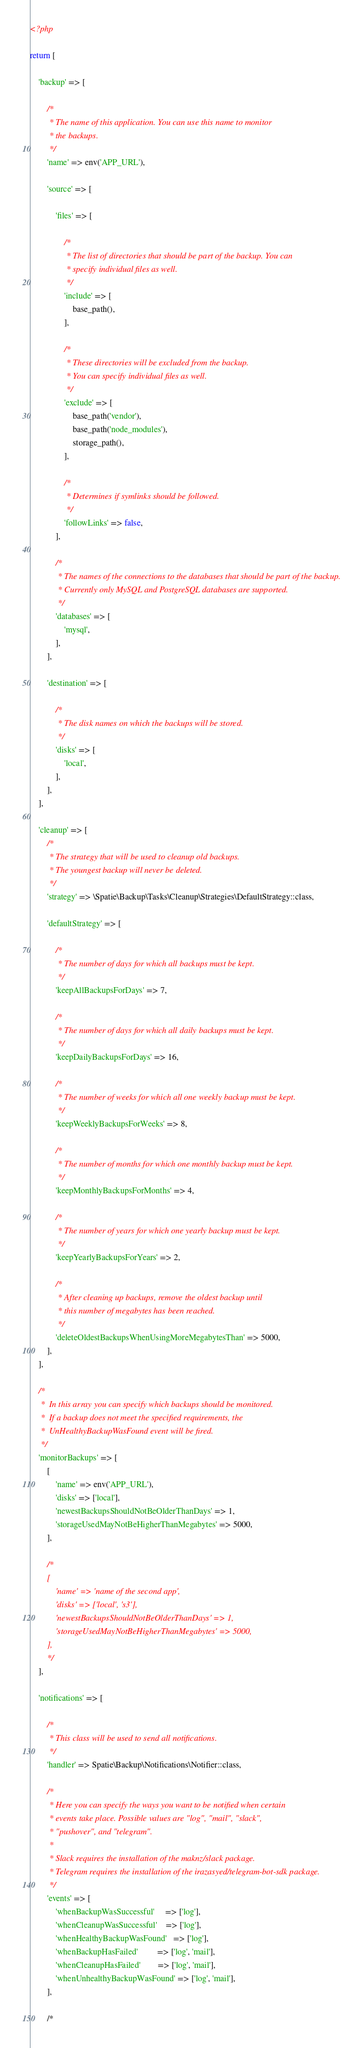<code> <loc_0><loc_0><loc_500><loc_500><_PHP_><?php

return [

    'backup' => [

        /*
         * The name of this application. You can use this name to monitor
         * the backups.
         */
        'name' => env('APP_URL'),

        'source' => [

            'files' => [

                /*
                 * The list of directories that should be part of the backup. You can
                 * specify individual files as well.
                 */
                'include' => [
                    base_path(),
                ],

                /*
                 * These directories will be excluded from the backup.
                 * You can specify individual files as well.
                 */
                'exclude' => [
                    base_path('vendor'),
                    base_path('node_modules'),
                    storage_path(),
                ],

                /*
                 * Determines if symlinks should be followed.
                 */
                'followLinks' => false,
            ],

            /*
             * The names of the connections to the databases that should be part of the backup.
             * Currently only MySQL and PostgreSQL databases are supported.
             */
            'databases' => [
                'mysql',
            ],
        ],

        'destination' => [

            /*
             * The disk names on which the backups will be stored.
             */
            'disks' => [
                'local',
            ],
        ],
    ],

    'cleanup' => [
        /*
         * The strategy that will be used to cleanup old backups.
         * The youngest backup will never be deleted.
         */
        'strategy' => \Spatie\Backup\Tasks\Cleanup\Strategies\DefaultStrategy::class,

        'defaultStrategy' => [

            /*
             * The number of days for which all backups must be kept.
             */
            'keepAllBackupsForDays' => 7,

            /*
             * The number of days for which all daily backups must be kept.
             */
            'keepDailyBackupsForDays' => 16,

            /*
             * The number of weeks for which all one weekly backup must be kept.
             */
            'keepWeeklyBackupsForWeeks' => 8,

            /*
             * The number of months for which one monthly backup must be kept.
             */
            'keepMonthlyBackupsForMonths' => 4,

            /*
             * The number of years for which one yearly backup must be kept.
             */
            'keepYearlyBackupsForYears' => 2,

            /*
             * After cleaning up backups, remove the oldest backup until
             * this number of megabytes has been reached.
             */
            'deleteOldestBackupsWhenUsingMoreMegabytesThan' => 5000,
        ],
    ],

    /*
     *  In this array you can specify which backups should be monitored.
     *  If a backup does not meet the specified requirements, the
     *  UnHealthyBackupWasFound event will be fired.
     */
    'monitorBackups' => [
        [
            'name' => env('APP_URL'),
            'disks' => ['local'],
            'newestBackupsShouldNotBeOlderThanDays' => 1,
            'storageUsedMayNotBeHigherThanMegabytes' => 5000,
        ],

        /*
        [
            'name' => 'name of the second app',
            'disks' => ['local', 's3'],
            'newestBackupsShouldNotBeOlderThanDays' => 1,
            'storageUsedMayNotBeHigherThanMegabytes' => 5000,
        ],
        */
    ],

    'notifications' => [

        /*
         * This class will be used to send all notifications.
         */
        'handler' => Spatie\Backup\Notifications\Notifier::class,

        /*
         * Here you can specify the ways you want to be notified when certain
         * events take place. Possible values are "log", "mail", "slack",
         * "pushover", and "telegram".
         *
         * Slack requires the installation of the maknz/slack package.
         * Telegram requires the installation of the irazasyed/telegram-bot-sdk package.
         */
        'events' => [
            'whenBackupWasSuccessful'     => ['log'],
            'whenCleanupWasSuccessful'    => ['log'],
            'whenHealthyBackupWasFound'   => ['log'],
            'whenBackupHasFailed'         => ['log', 'mail'],
            'whenCleanupHasFailed'        => ['log', 'mail'],
            'whenUnhealthyBackupWasFound' => ['log', 'mail'],
        ],

        /*</code> 